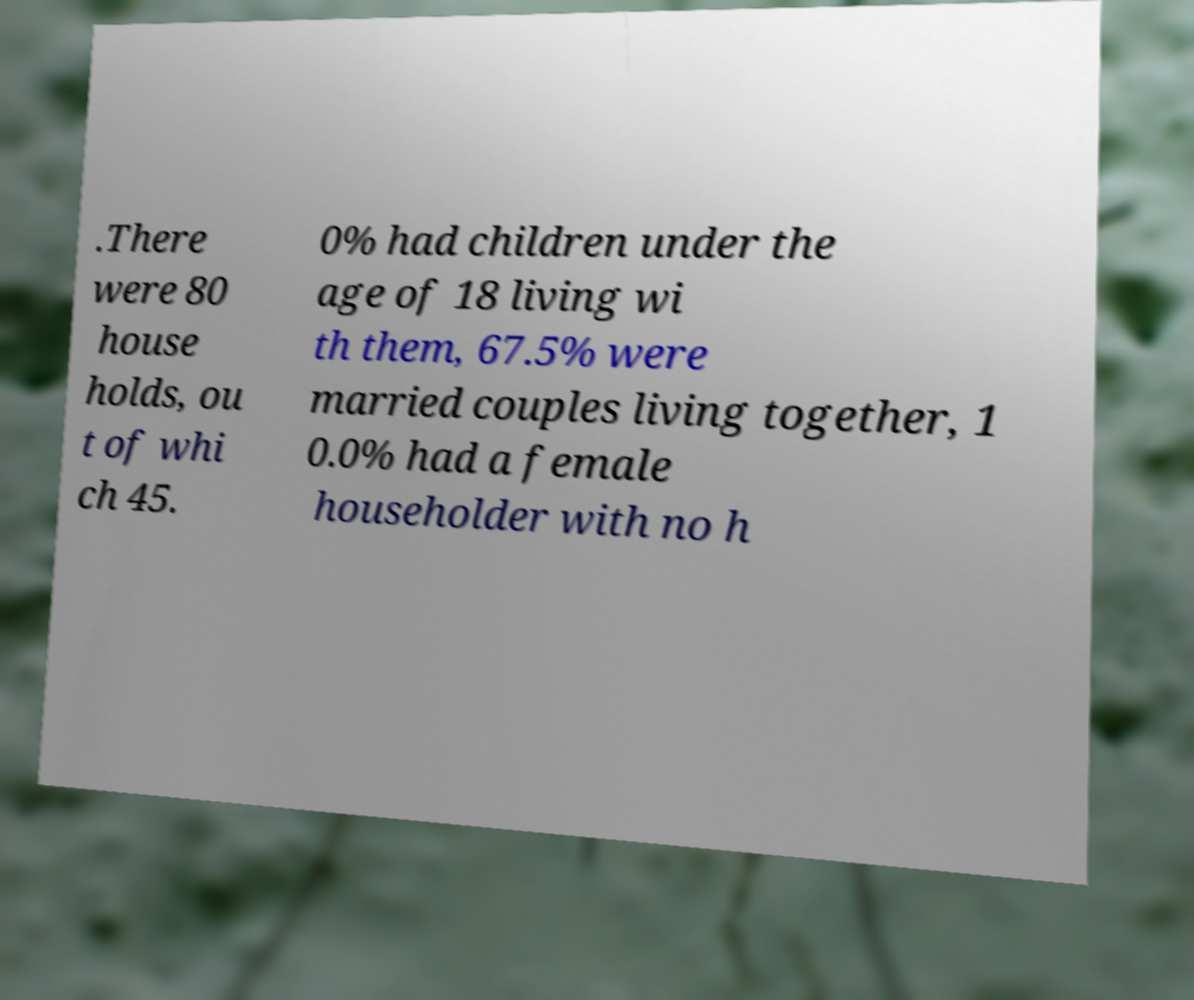There's text embedded in this image that I need extracted. Can you transcribe it verbatim? .There were 80 house holds, ou t of whi ch 45. 0% had children under the age of 18 living wi th them, 67.5% were married couples living together, 1 0.0% had a female householder with no h 